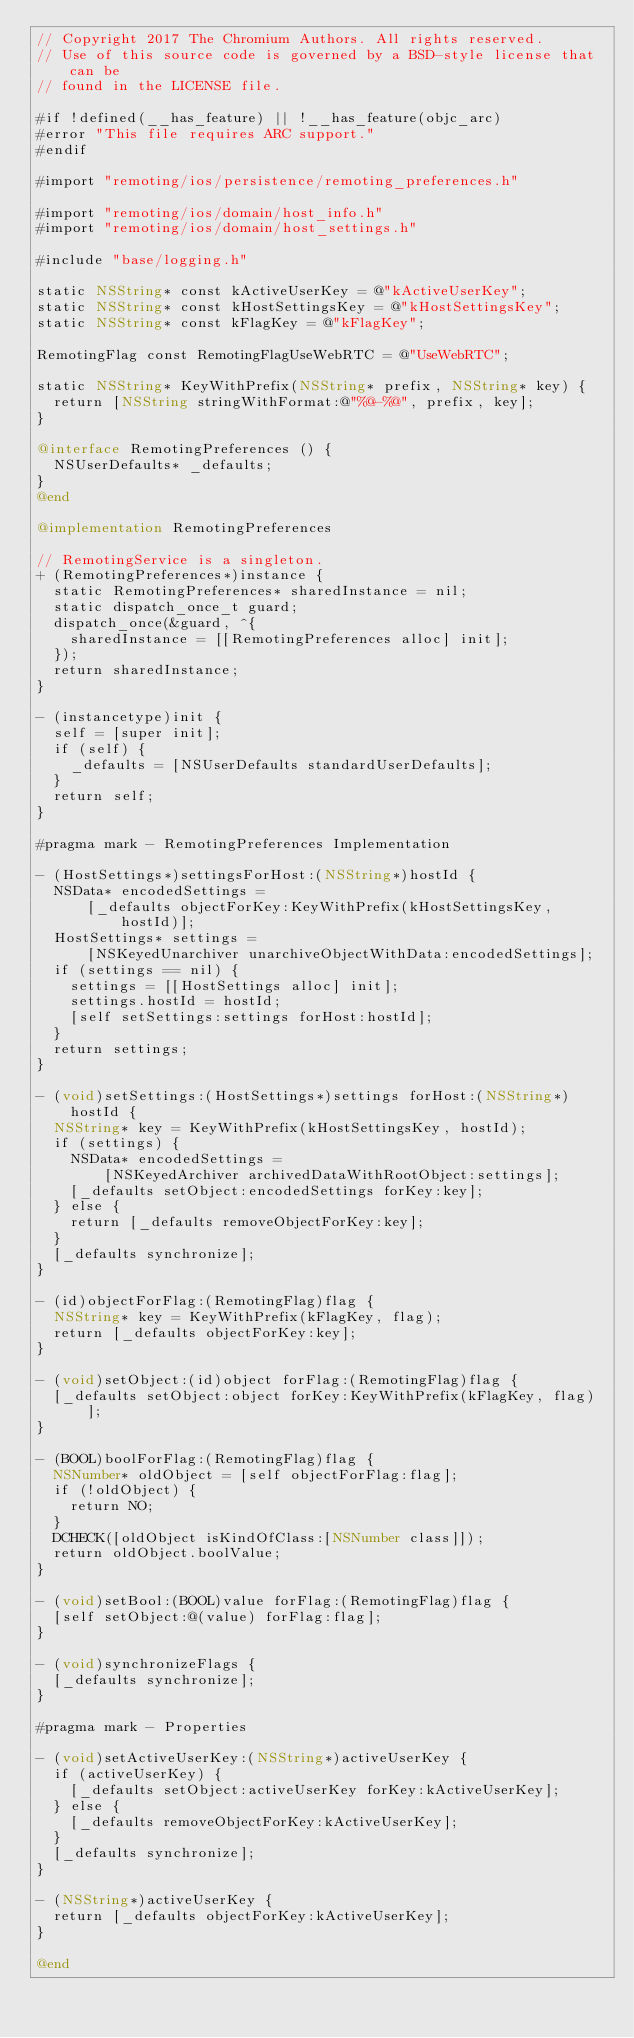Convert code to text. <code><loc_0><loc_0><loc_500><loc_500><_ObjectiveC_>// Copyright 2017 The Chromium Authors. All rights reserved.
// Use of this source code is governed by a BSD-style license that can be
// found in the LICENSE file.

#if !defined(__has_feature) || !__has_feature(objc_arc)
#error "This file requires ARC support."
#endif

#import "remoting/ios/persistence/remoting_preferences.h"

#import "remoting/ios/domain/host_info.h"
#import "remoting/ios/domain/host_settings.h"

#include "base/logging.h"

static NSString* const kActiveUserKey = @"kActiveUserKey";
static NSString* const kHostSettingsKey = @"kHostSettingsKey";
static NSString* const kFlagKey = @"kFlagKey";

RemotingFlag const RemotingFlagUseWebRTC = @"UseWebRTC";

static NSString* KeyWithPrefix(NSString* prefix, NSString* key) {
  return [NSString stringWithFormat:@"%@-%@", prefix, key];
}

@interface RemotingPreferences () {
  NSUserDefaults* _defaults;
}
@end

@implementation RemotingPreferences

// RemotingService is a singleton.
+ (RemotingPreferences*)instance {
  static RemotingPreferences* sharedInstance = nil;
  static dispatch_once_t guard;
  dispatch_once(&guard, ^{
    sharedInstance = [[RemotingPreferences alloc] init];
  });
  return sharedInstance;
}

- (instancetype)init {
  self = [super init];
  if (self) {
    _defaults = [NSUserDefaults standardUserDefaults];
  }
  return self;
}

#pragma mark - RemotingPreferences Implementation

- (HostSettings*)settingsForHost:(NSString*)hostId {
  NSData* encodedSettings =
      [_defaults objectForKey:KeyWithPrefix(kHostSettingsKey, hostId)];
  HostSettings* settings =
      [NSKeyedUnarchiver unarchiveObjectWithData:encodedSettings];
  if (settings == nil) {
    settings = [[HostSettings alloc] init];
    settings.hostId = hostId;
    [self setSettings:settings forHost:hostId];
  }
  return settings;
}

- (void)setSettings:(HostSettings*)settings forHost:(NSString*)hostId {
  NSString* key = KeyWithPrefix(kHostSettingsKey, hostId);
  if (settings) {
    NSData* encodedSettings =
        [NSKeyedArchiver archivedDataWithRootObject:settings];
    [_defaults setObject:encodedSettings forKey:key];
  } else {
    return [_defaults removeObjectForKey:key];
  }
  [_defaults synchronize];
}

- (id)objectForFlag:(RemotingFlag)flag {
  NSString* key = KeyWithPrefix(kFlagKey, flag);
  return [_defaults objectForKey:key];
}

- (void)setObject:(id)object forFlag:(RemotingFlag)flag {
  [_defaults setObject:object forKey:KeyWithPrefix(kFlagKey, flag)];
}

- (BOOL)boolForFlag:(RemotingFlag)flag {
  NSNumber* oldObject = [self objectForFlag:flag];
  if (!oldObject) {
    return NO;
  }
  DCHECK([oldObject isKindOfClass:[NSNumber class]]);
  return oldObject.boolValue;
}

- (void)setBool:(BOOL)value forFlag:(RemotingFlag)flag {
  [self setObject:@(value) forFlag:flag];
}

- (void)synchronizeFlags {
  [_defaults synchronize];
}

#pragma mark - Properties

- (void)setActiveUserKey:(NSString*)activeUserKey {
  if (activeUserKey) {
    [_defaults setObject:activeUserKey forKey:kActiveUserKey];
  } else {
    [_defaults removeObjectForKey:kActiveUserKey];
  }
  [_defaults synchronize];
}

- (NSString*)activeUserKey {
  return [_defaults objectForKey:kActiveUserKey];
}

@end
</code> 